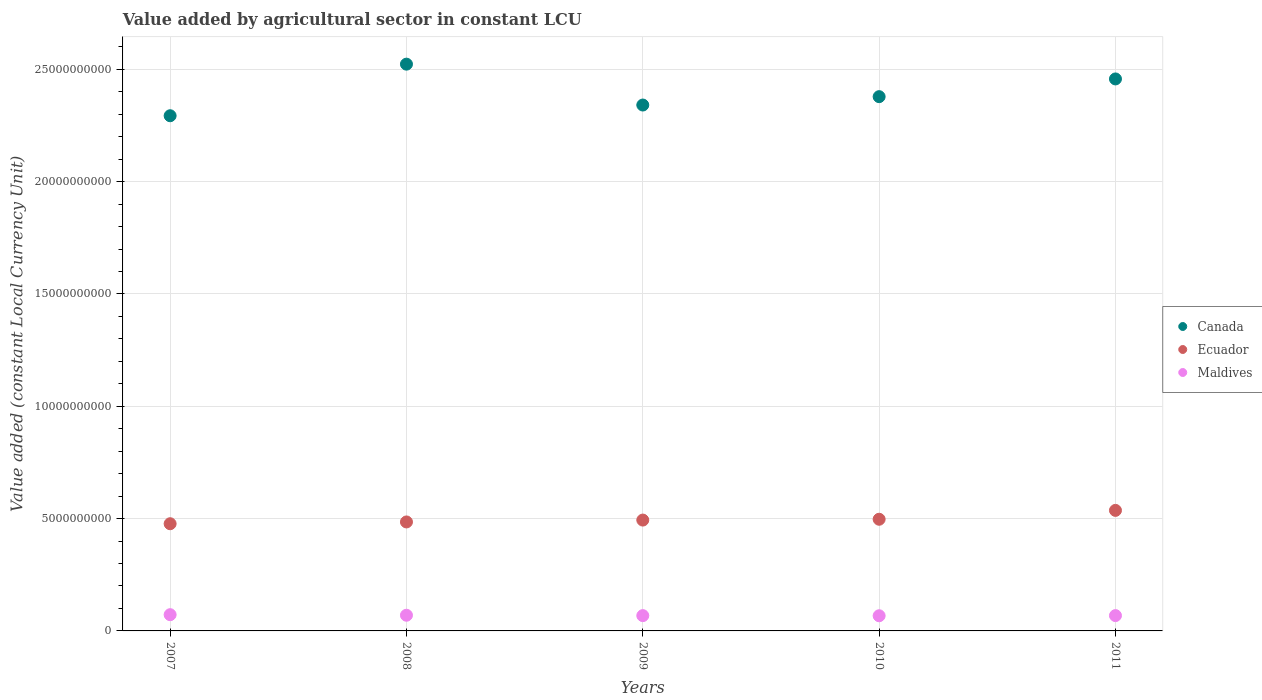How many different coloured dotlines are there?
Offer a terse response. 3. What is the value added by agricultural sector in Ecuador in 2011?
Provide a short and direct response. 5.37e+09. Across all years, what is the maximum value added by agricultural sector in Maldives?
Ensure brevity in your answer.  7.23e+08. Across all years, what is the minimum value added by agricultural sector in Ecuador?
Your answer should be very brief. 4.77e+09. In which year was the value added by agricultural sector in Ecuador maximum?
Ensure brevity in your answer.  2011. What is the total value added by agricultural sector in Canada in the graph?
Provide a succinct answer. 1.20e+11. What is the difference between the value added by agricultural sector in Ecuador in 2010 and that in 2011?
Offer a very short reply. -3.95e+08. What is the difference between the value added by agricultural sector in Maldives in 2008 and the value added by agricultural sector in Ecuador in 2010?
Provide a short and direct response. -4.27e+09. What is the average value added by agricultural sector in Ecuador per year?
Provide a succinct answer. 4.98e+09. In the year 2009, what is the difference between the value added by agricultural sector in Canada and value added by agricultural sector in Ecuador?
Your answer should be very brief. 1.85e+1. What is the ratio of the value added by agricultural sector in Ecuador in 2007 to that in 2011?
Give a very brief answer. 0.89. What is the difference between the highest and the second highest value added by agricultural sector in Maldives?
Provide a succinct answer. 2.45e+07. What is the difference between the highest and the lowest value added by agricultural sector in Ecuador?
Your response must be concise. 5.94e+08. Is the sum of the value added by agricultural sector in Maldives in 2008 and 2011 greater than the maximum value added by agricultural sector in Ecuador across all years?
Ensure brevity in your answer.  No. Is the value added by agricultural sector in Maldives strictly greater than the value added by agricultural sector in Canada over the years?
Your answer should be very brief. No. Is the value added by agricultural sector in Canada strictly less than the value added by agricultural sector in Maldives over the years?
Keep it short and to the point. No. How many years are there in the graph?
Give a very brief answer. 5. Are the values on the major ticks of Y-axis written in scientific E-notation?
Provide a short and direct response. No. How many legend labels are there?
Keep it short and to the point. 3. What is the title of the graph?
Give a very brief answer. Value added by agricultural sector in constant LCU. Does "Ethiopia" appear as one of the legend labels in the graph?
Provide a succinct answer. No. What is the label or title of the Y-axis?
Your answer should be compact. Value added (constant Local Currency Unit). What is the Value added (constant Local Currency Unit) of Canada in 2007?
Provide a short and direct response. 2.29e+1. What is the Value added (constant Local Currency Unit) of Ecuador in 2007?
Your answer should be very brief. 4.77e+09. What is the Value added (constant Local Currency Unit) of Maldives in 2007?
Offer a very short reply. 7.23e+08. What is the Value added (constant Local Currency Unit) in Canada in 2008?
Keep it short and to the point. 2.52e+1. What is the Value added (constant Local Currency Unit) of Ecuador in 2008?
Offer a terse response. 4.85e+09. What is the Value added (constant Local Currency Unit) of Maldives in 2008?
Ensure brevity in your answer.  6.98e+08. What is the Value added (constant Local Currency Unit) in Canada in 2009?
Provide a short and direct response. 2.34e+1. What is the Value added (constant Local Currency Unit) in Ecuador in 2009?
Your answer should be very brief. 4.93e+09. What is the Value added (constant Local Currency Unit) in Maldives in 2009?
Keep it short and to the point. 6.81e+08. What is the Value added (constant Local Currency Unit) in Canada in 2010?
Keep it short and to the point. 2.38e+1. What is the Value added (constant Local Currency Unit) in Ecuador in 2010?
Make the answer very short. 4.97e+09. What is the Value added (constant Local Currency Unit) of Maldives in 2010?
Give a very brief answer. 6.75e+08. What is the Value added (constant Local Currency Unit) in Canada in 2011?
Your response must be concise. 2.46e+1. What is the Value added (constant Local Currency Unit) in Ecuador in 2011?
Provide a short and direct response. 5.37e+09. What is the Value added (constant Local Currency Unit) of Maldives in 2011?
Offer a terse response. 6.82e+08. Across all years, what is the maximum Value added (constant Local Currency Unit) in Canada?
Offer a terse response. 2.52e+1. Across all years, what is the maximum Value added (constant Local Currency Unit) of Ecuador?
Give a very brief answer. 5.37e+09. Across all years, what is the maximum Value added (constant Local Currency Unit) of Maldives?
Make the answer very short. 7.23e+08. Across all years, what is the minimum Value added (constant Local Currency Unit) of Canada?
Offer a very short reply. 2.29e+1. Across all years, what is the minimum Value added (constant Local Currency Unit) in Ecuador?
Give a very brief answer. 4.77e+09. Across all years, what is the minimum Value added (constant Local Currency Unit) of Maldives?
Provide a succinct answer. 6.75e+08. What is the total Value added (constant Local Currency Unit) in Canada in the graph?
Your response must be concise. 1.20e+11. What is the total Value added (constant Local Currency Unit) in Ecuador in the graph?
Keep it short and to the point. 2.49e+1. What is the total Value added (constant Local Currency Unit) of Maldives in the graph?
Make the answer very short. 3.46e+09. What is the difference between the Value added (constant Local Currency Unit) of Canada in 2007 and that in 2008?
Give a very brief answer. -2.30e+09. What is the difference between the Value added (constant Local Currency Unit) in Ecuador in 2007 and that in 2008?
Give a very brief answer. -7.96e+07. What is the difference between the Value added (constant Local Currency Unit) in Maldives in 2007 and that in 2008?
Provide a short and direct response. 2.45e+07. What is the difference between the Value added (constant Local Currency Unit) of Canada in 2007 and that in 2009?
Keep it short and to the point. -4.77e+08. What is the difference between the Value added (constant Local Currency Unit) of Ecuador in 2007 and that in 2009?
Ensure brevity in your answer.  -1.63e+08. What is the difference between the Value added (constant Local Currency Unit) of Maldives in 2007 and that in 2009?
Offer a terse response. 4.17e+07. What is the difference between the Value added (constant Local Currency Unit) in Canada in 2007 and that in 2010?
Offer a terse response. -8.49e+08. What is the difference between the Value added (constant Local Currency Unit) of Ecuador in 2007 and that in 2010?
Ensure brevity in your answer.  -1.99e+08. What is the difference between the Value added (constant Local Currency Unit) in Maldives in 2007 and that in 2010?
Make the answer very short. 4.77e+07. What is the difference between the Value added (constant Local Currency Unit) in Canada in 2007 and that in 2011?
Give a very brief answer. -1.64e+09. What is the difference between the Value added (constant Local Currency Unit) in Ecuador in 2007 and that in 2011?
Offer a very short reply. -5.94e+08. What is the difference between the Value added (constant Local Currency Unit) in Maldives in 2007 and that in 2011?
Offer a terse response. 4.06e+07. What is the difference between the Value added (constant Local Currency Unit) of Canada in 2008 and that in 2009?
Your answer should be compact. 1.82e+09. What is the difference between the Value added (constant Local Currency Unit) in Ecuador in 2008 and that in 2009?
Ensure brevity in your answer.  -8.32e+07. What is the difference between the Value added (constant Local Currency Unit) in Maldives in 2008 and that in 2009?
Give a very brief answer. 1.72e+07. What is the difference between the Value added (constant Local Currency Unit) in Canada in 2008 and that in 2010?
Provide a succinct answer. 1.45e+09. What is the difference between the Value added (constant Local Currency Unit) in Ecuador in 2008 and that in 2010?
Make the answer very short. -1.20e+08. What is the difference between the Value added (constant Local Currency Unit) in Maldives in 2008 and that in 2010?
Your response must be concise. 2.32e+07. What is the difference between the Value added (constant Local Currency Unit) in Canada in 2008 and that in 2011?
Provide a short and direct response. 6.58e+08. What is the difference between the Value added (constant Local Currency Unit) of Ecuador in 2008 and that in 2011?
Your answer should be compact. -5.14e+08. What is the difference between the Value added (constant Local Currency Unit) of Maldives in 2008 and that in 2011?
Provide a short and direct response. 1.60e+07. What is the difference between the Value added (constant Local Currency Unit) in Canada in 2009 and that in 2010?
Ensure brevity in your answer.  -3.73e+08. What is the difference between the Value added (constant Local Currency Unit) of Ecuador in 2009 and that in 2010?
Make the answer very short. -3.65e+07. What is the difference between the Value added (constant Local Currency Unit) in Maldives in 2009 and that in 2010?
Provide a short and direct response. 5.98e+06. What is the difference between the Value added (constant Local Currency Unit) of Canada in 2009 and that in 2011?
Offer a terse response. -1.16e+09. What is the difference between the Value added (constant Local Currency Unit) of Ecuador in 2009 and that in 2011?
Provide a succinct answer. -4.31e+08. What is the difference between the Value added (constant Local Currency Unit) of Maldives in 2009 and that in 2011?
Offer a terse response. -1.15e+06. What is the difference between the Value added (constant Local Currency Unit) in Canada in 2010 and that in 2011?
Your answer should be compact. -7.89e+08. What is the difference between the Value added (constant Local Currency Unit) of Ecuador in 2010 and that in 2011?
Offer a terse response. -3.95e+08. What is the difference between the Value added (constant Local Currency Unit) in Maldives in 2010 and that in 2011?
Your response must be concise. -7.13e+06. What is the difference between the Value added (constant Local Currency Unit) of Canada in 2007 and the Value added (constant Local Currency Unit) of Ecuador in 2008?
Provide a succinct answer. 1.81e+1. What is the difference between the Value added (constant Local Currency Unit) in Canada in 2007 and the Value added (constant Local Currency Unit) in Maldives in 2008?
Your response must be concise. 2.22e+1. What is the difference between the Value added (constant Local Currency Unit) of Ecuador in 2007 and the Value added (constant Local Currency Unit) of Maldives in 2008?
Provide a succinct answer. 4.07e+09. What is the difference between the Value added (constant Local Currency Unit) of Canada in 2007 and the Value added (constant Local Currency Unit) of Ecuador in 2009?
Offer a terse response. 1.80e+1. What is the difference between the Value added (constant Local Currency Unit) in Canada in 2007 and the Value added (constant Local Currency Unit) in Maldives in 2009?
Provide a succinct answer. 2.23e+1. What is the difference between the Value added (constant Local Currency Unit) in Ecuador in 2007 and the Value added (constant Local Currency Unit) in Maldives in 2009?
Keep it short and to the point. 4.09e+09. What is the difference between the Value added (constant Local Currency Unit) in Canada in 2007 and the Value added (constant Local Currency Unit) in Ecuador in 2010?
Ensure brevity in your answer.  1.80e+1. What is the difference between the Value added (constant Local Currency Unit) in Canada in 2007 and the Value added (constant Local Currency Unit) in Maldives in 2010?
Keep it short and to the point. 2.23e+1. What is the difference between the Value added (constant Local Currency Unit) in Ecuador in 2007 and the Value added (constant Local Currency Unit) in Maldives in 2010?
Keep it short and to the point. 4.10e+09. What is the difference between the Value added (constant Local Currency Unit) of Canada in 2007 and the Value added (constant Local Currency Unit) of Ecuador in 2011?
Your answer should be compact. 1.76e+1. What is the difference between the Value added (constant Local Currency Unit) of Canada in 2007 and the Value added (constant Local Currency Unit) of Maldives in 2011?
Make the answer very short. 2.23e+1. What is the difference between the Value added (constant Local Currency Unit) of Ecuador in 2007 and the Value added (constant Local Currency Unit) of Maldives in 2011?
Offer a very short reply. 4.09e+09. What is the difference between the Value added (constant Local Currency Unit) in Canada in 2008 and the Value added (constant Local Currency Unit) in Ecuador in 2009?
Provide a succinct answer. 2.03e+1. What is the difference between the Value added (constant Local Currency Unit) of Canada in 2008 and the Value added (constant Local Currency Unit) of Maldives in 2009?
Ensure brevity in your answer.  2.46e+1. What is the difference between the Value added (constant Local Currency Unit) in Ecuador in 2008 and the Value added (constant Local Currency Unit) in Maldives in 2009?
Ensure brevity in your answer.  4.17e+09. What is the difference between the Value added (constant Local Currency Unit) of Canada in 2008 and the Value added (constant Local Currency Unit) of Ecuador in 2010?
Your answer should be compact. 2.03e+1. What is the difference between the Value added (constant Local Currency Unit) in Canada in 2008 and the Value added (constant Local Currency Unit) in Maldives in 2010?
Your response must be concise. 2.46e+1. What is the difference between the Value added (constant Local Currency Unit) of Ecuador in 2008 and the Value added (constant Local Currency Unit) of Maldives in 2010?
Your answer should be compact. 4.18e+09. What is the difference between the Value added (constant Local Currency Unit) in Canada in 2008 and the Value added (constant Local Currency Unit) in Ecuador in 2011?
Your response must be concise. 1.99e+1. What is the difference between the Value added (constant Local Currency Unit) in Canada in 2008 and the Value added (constant Local Currency Unit) in Maldives in 2011?
Your response must be concise. 2.45e+1. What is the difference between the Value added (constant Local Currency Unit) of Ecuador in 2008 and the Value added (constant Local Currency Unit) of Maldives in 2011?
Give a very brief answer. 4.17e+09. What is the difference between the Value added (constant Local Currency Unit) of Canada in 2009 and the Value added (constant Local Currency Unit) of Ecuador in 2010?
Make the answer very short. 1.84e+1. What is the difference between the Value added (constant Local Currency Unit) of Canada in 2009 and the Value added (constant Local Currency Unit) of Maldives in 2010?
Provide a short and direct response. 2.27e+1. What is the difference between the Value added (constant Local Currency Unit) in Ecuador in 2009 and the Value added (constant Local Currency Unit) in Maldives in 2010?
Make the answer very short. 4.26e+09. What is the difference between the Value added (constant Local Currency Unit) in Canada in 2009 and the Value added (constant Local Currency Unit) in Ecuador in 2011?
Provide a succinct answer. 1.80e+1. What is the difference between the Value added (constant Local Currency Unit) of Canada in 2009 and the Value added (constant Local Currency Unit) of Maldives in 2011?
Offer a terse response. 2.27e+1. What is the difference between the Value added (constant Local Currency Unit) of Ecuador in 2009 and the Value added (constant Local Currency Unit) of Maldives in 2011?
Your answer should be very brief. 4.25e+09. What is the difference between the Value added (constant Local Currency Unit) of Canada in 2010 and the Value added (constant Local Currency Unit) of Ecuador in 2011?
Give a very brief answer. 1.84e+1. What is the difference between the Value added (constant Local Currency Unit) in Canada in 2010 and the Value added (constant Local Currency Unit) in Maldives in 2011?
Your answer should be compact. 2.31e+1. What is the difference between the Value added (constant Local Currency Unit) in Ecuador in 2010 and the Value added (constant Local Currency Unit) in Maldives in 2011?
Provide a short and direct response. 4.29e+09. What is the average Value added (constant Local Currency Unit) of Canada per year?
Give a very brief answer. 2.40e+1. What is the average Value added (constant Local Currency Unit) in Ecuador per year?
Your answer should be compact. 4.98e+09. What is the average Value added (constant Local Currency Unit) of Maldives per year?
Offer a very short reply. 6.92e+08. In the year 2007, what is the difference between the Value added (constant Local Currency Unit) of Canada and Value added (constant Local Currency Unit) of Ecuador?
Keep it short and to the point. 1.82e+1. In the year 2007, what is the difference between the Value added (constant Local Currency Unit) of Canada and Value added (constant Local Currency Unit) of Maldives?
Keep it short and to the point. 2.22e+1. In the year 2007, what is the difference between the Value added (constant Local Currency Unit) in Ecuador and Value added (constant Local Currency Unit) in Maldives?
Offer a terse response. 4.05e+09. In the year 2008, what is the difference between the Value added (constant Local Currency Unit) in Canada and Value added (constant Local Currency Unit) in Ecuador?
Provide a short and direct response. 2.04e+1. In the year 2008, what is the difference between the Value added (constant Local Currency Unit) in Canada and Value added (constant Local Currency Unit) in Maldives?
Offer a terse response. 2.45e+1. In the year 2008, what is the difference between the Value added (constant Local Currency Unit) of Ecuador and Value added (constant Local Currency Unit) of Maldives?
Give a very brief answer. 4.15e+09. In the year 2009, what is the difference between the Value added (constant Local Currency Unit) in Canada and Value added (constant Local Currency Unit) in Ecuador?
Ensure brevity in your answer.  1.85e+1. In the year 2009, what is the difference between the Value added (constant Local Currency Unit) of Canada and Value added (constant Local Currency Unit) of Maldives?
Keep it short and to the point. 2.27e+1. In the year 2009, what is the difference between the Value added (constant Local Currency Unit) in Ecuador and Value added (constant Local Currency Unit) in Maldives?
Offer a terse response. 4.25e+09. In the year 2010, what is the difference between the Value added (constant Local Currency Unit) in Canada and Value added (constant Local Currency Unit) in Ecuador?
Give a very brief answer. 1.88e+1. In the year 2010, what is the difference between the Value added (constant Local Currency Unit) in Canada and Value added (constant Local Currency Unit) in Maldives?
Your answer should be compact. 2.31e+1. In the year 2010, what is the difference between the Value added (constant Local Currency Unit) in Ecuador and Value added (constant Local Currency Unit) in Maldives?
Your answer should be very brief. 4.30e+09. In the year 2011, what is the difference between the Value added (constant Local Currency Unit) of Canada and Value added (constant Local Currency Unit) of Ecuador?
Provide a short and direct response. 1.92e+1. In the year 2011, what is the difference between the Value added (constant Local Currency Unit) in Canada and Value added (constant Local Currency Unit) in Maldives?
Your response must be concise. 2.39e+1. In the year 2011, what is the difference between the Value added (constant Local Currency Unit) in Ecuador and Value added (constant Local Currency Unit) in Maldives?
Offer a terse response. 4.68e+09. What is the ratio of the Value added (constant Local Currency Unit) of Canada in 2007 to that in 2008?
Give a very brief answer. 0.91. What is the ratio of the Value added (constant Local Currency Unit) of Ecuador in 2007 to that in 2008?
Provide a succinct answer. 0.98. What is the ratio of the Value added (constant Local Currency Unit) of Maldives in 2007 to that in 2008?
Keep it short and to the point. 1.04. What is the ratio of the Value added (constant Local Currency Unit) of Canada in 2007 to that in 2009?
Make the answer very short. 0.98. What is the ratio of the Value added (constant Local Currency Unit) in Ecuador in 2007 to that in 2009?
Offer a very short reply. 0.97. What is the ratio of the Value added (constant Local Currency Unit) of Maldives in 2007 to that in 2009?
Offer a very short reply. 1.06. What is the ratio of the Value added (constant Local Currency Unit) of Canada in 2007 to that in 2010?
Ensure brevity in your answer.  0.96. What is the ratio of the Value added (constant Local Currency Unit) of Ecuador in 2007 to that in 2010?
Ensure brevity in your answer.  0.96. What is the ratio of the Value added (constant Local Currency Unit) in Maldives in 2007 to that in 2010?
Your answer should be very brief. 1.07. What is the ratio of the Value added (constant Local Currency Unit) of Canada in 2007 to that in 2011?
Give a very brief answer. 0.93. What is the ratio of the Value added (constant Local Currency Unit) in Ecuador in 2007 to that in 2011?
Provide a short and direct response. 0.89. What is the ratio of the Value added (constant Local Currency Unit) of Maldives in 2007 to that in 2011?
Provide a short and direct response. 1.06. What is the ratio of the Value added (constant Local Currency Unit) in Canada in 2008 to that in 2009?
Your response must be concise. 1.08. What is the ratio of the Value added (constant Local Currency Unit) in Ecuador in 2008 to that in 2009?
Make the answer very short. 0.98. What is the ratio of the Value added (constant Local Currency Unit) in Maldives in 2008 to that in 2009?
Provide a short and direct response. 1.03. What is the ratio of the Value added (constant Local Currency Unit) of Canada in 2008 to that in 2010?
Your answer should be very brief. 1.06. What is the ratio of the Value added (constant Local Currency Unit) of Ecuador in 2008 to that in 2010?
Provide a succinct answer. 0.98. What is the ratio of the Value added (constant Local Currency Unit) in Maldives in 2008 to that in 2010?
Your answer should be compact. 1.03. What is the ratio of the Value added (constant Local Currency Unit) of Canada in 2008 to that in 2011?
Make the answer very short. 1.03. What is the ratio of the Value added (constant Local Currency Unit) in Ecuador in 2008 to that in 2011?
Ensure brevity in your answer.  0.9. What is the ratio of the Value added (constant Local Currency Unit) of Maldives in 2008 to that in 2011?
Provide a short and direct response. 1.02. What is the ratio of the Value added (constant Local Currency Unit) of Canada in 2009 to that in 2010?
Your answer should be very brief. 0.98. What is the ratio of the Value added (constant Local Currency Unit) in Maldives in 2009 to that in 2010?
Provide a short and direct response. 1.01. What is the ratio of the Value added (constant Local Currency Unit) in Canada in 2009 to that in 2011?
Your answer should be very brief. 0.95. What is the ratio of the Value added (constant Local Currency Unit) of Ecuador in 2009 to that in 2011?
Offer a terse response. 0.92. What is the ratio of the Value added (constant Local Currency Unit) in Maldives in 2009 to that in 2011?
Give a very brief answer. 1. What is the ratio of the Value added (constant Local Currency Unit) in Canada in 2010 to that in 2011?
Make the answer very short. 0.97. What is the ratio of the Value added (constant Local Currency Unit) of Ecuador in 2010 to that in 2011?
Make the answer very short. 0.93. What is the difference between the highest and the second highest Value added (constant Local Currency Unit) in Canada?
Provide a succinct answer. 6.58e+08. What is the difference between the highest and the second highest Value added (constant Local Currency Unit) of Ecuador?
Provide a short and direct response. 3.95e+08. What is the difference between the highest and the second highest Value added (constant Local Currency Unit) in Maldives?
Offer a terse response. 2.45e+07. What is the difference between the highest and the lowest Value added (constant Local Currency Unit) in Canada?
Make the answer very short. 2.30e+09. What is the difference between the highest and the lowest Value added (constant Local Currency Unit) in Ecuador?
Offer a terse response. 5.94e+08. What is the difference between the highest and the lowest Value added (constant Local Currency Unit) in Maldives?
Your answer should be very brief. 4.77e+07. 